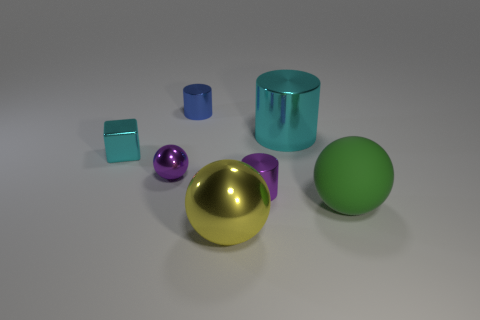What is the size of the shiny object that is the same color as the small block?
Offer a very short reply. Large. Is the number of blue shiny cylinders on the left side of the tiny cyan metal block less than the number of large green balls in front of the big matte object?
Your answer should be compact. No. What number of brown objects are either large balls or big rubber things?
Offer a very short reply. 0. Is the number of yellow shiny objects that are behind the blue thing the same as the number of big green spheres?
Make the answer very short. No. What number of things are either blocks or small purple objects that are right of the big yellow metallic sphere?
Offer a terse response. 2. Do the tiny shiny ball and the block have the same color?
Keep it short and to the point. No. Is there a large red cube made of the same material as the large yellow ball?
Provide a short and direct response. No. What color is the large metal thing that is the same shape as the big green matte thing?
Provide a short and direct response. Yellow. Is the purple cylinder made of the same material as the large ball to the left of the green thing?
Make the answer very short. Yes. What shape is the large metal thing behind the big green sphere on the right side of the small cyan block?
Your answer should be very brief. Cylinder. 